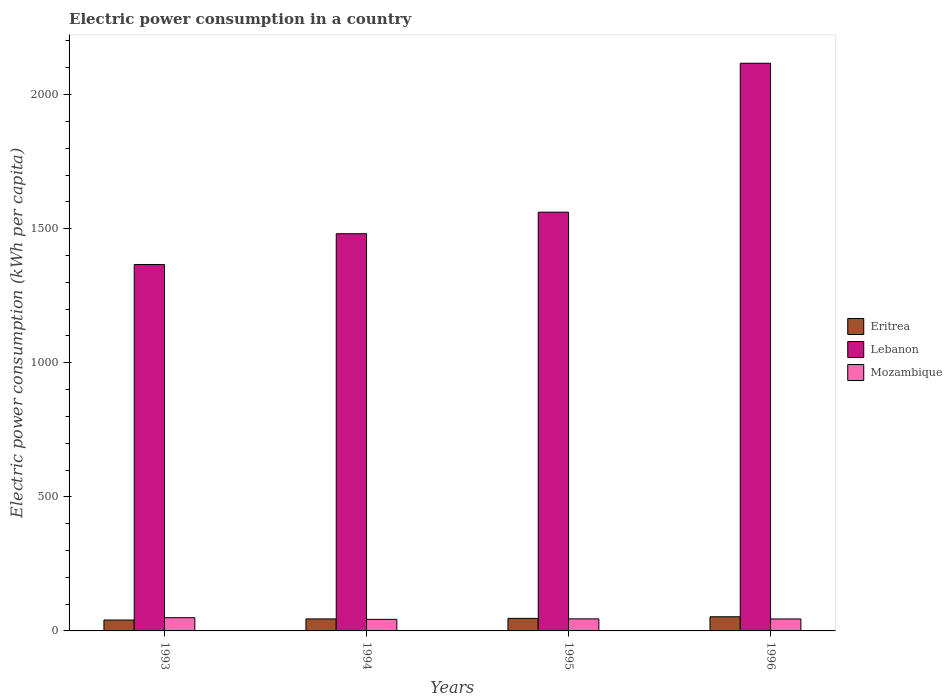How many different coloured bars are there?
Provide a succinct answer. 3. Are the number of bars on each tick of the X-axis equal?
Ensure brevity in your answer.  Yes. How many bars are there on the 2nd tick from the left?
Offer a terse response. 3. How many bars are there on the 3rd tick from the right?
Offer a terse response. 3. What is the electric power consumption in in Lebanon in 1994?
Your answer should be very brief. 1481.18. Across all years, what is the maximum electric power consumption in in Lebanon?
Offer a very short reply. 2116.92. Across all years, what is the minimum electric power consumption in in Eritrea?
Keep it short and to the point. 40.62. In which year was the electric power consumption in in Mozambique maximum?
Your answer should be very brief. 1993. In which year was the electric power consumption in in Eritrea minimum?
Offer a terse response. 1993. What is the total electric power consumption in in Eritrea in the graph?
Provide a short and direct response. 184.96. What is the difference between the electric power consumption in in Lebanon in 1995 and that in 1996?
Provide a short and direct response. -555.31. What is the difference between the electric power consumption in in Eritrea in 1993 and the electric power consumption in in Mozambique in 1996?
Provide a succinct answer. -3.98. What is the average electric power consumption in in Mozambique per year?
Provide a succinct answer. 45.47. In the year 1993, what is the difference between the electric power consumption in in Mozambique and electric power consumption in in Eritrea?
Your response must be concise. 8.65. In how many years, is the electric power consumption in in Eritrea greater than 1000 kWh per capita?
Provide a succinct answer. 0. What is the ratio of the electric power consumption in in Mozambique in 1994 to that in 1995?
Give a very brief answer. 0.96. Is the difference between the electric power consumption in in Mozambique in 1994 and 1996 greater than the difference between the electric power consumption in in Eritrea in 1994 and 1996?
Your answer should be compact. Yes. What is the difference between the highest and the second highest electric power consumption in in Eritrea?
Ensure brevity in your answer.  5.99. What is the difference between the highest and the lowest electric power consumption in in Eritrea?
Ensure brevity in your answer.  12.15. Is the sum of the electric power consumption in in Lebanon in 1993 and 1994 greater than the maximum electric power consumption in in Mozambique across all years?
Your response must be concise. Yes. What does the 1st bar from the left in 1995 represents?
Provide a short and direct response. Eritrea. What does the 2nd bar from the right in 1994 represents?
Make the answer very short. Lebanon. Is it the case that in every year, the sum of the electric power consumption in in Lebanon and electric power consumption in in Mozambique is greater than the electric power consumption in in Eritrea?
Your answer should be compact. Yes. How many years are there in the graph?
Offer a terse response. 4. Does the graph contain grids?
Provide a short and direct response. No. How many legend labels are there?
Your answer should be very brief. 3. How are the legend labels stacked?
Provide a succinct answer. Vertical. What is the title of the graph?
Keep it short and to the point. Electric power consumption in a country. What is the label or title of the Y-axis?
Give a very brief answer. Electric power consumption (kWh per capita). What is the Electric power consumption (kWh per capita) in Eritrea in 1993?
Provide a short and direct response. 40.62. What is the Electric power consumption (kWh per capita) in Lebanon in 1993?
Offer a terse response. 1366.49. What is the Electric power consumption (kWh per capita) of Mozambique in 1993?
Offer a terse response. 49.27. What is the Electric power consumption (kWh per capita) of Eritrea in 1994?
Keep it short and to the point. 44.79. What is the Electric power consumption (kWh per capita) in Lebanon in 1994?
Provide a succinct answer. 1481.18. What is the Electric power consumption (kWh per capita) in Mozambique in 1994?
Provide a short and direct response. 43.09. What is the Electric power consumption (kWh per capita) in Eritrea in 1995?
Ensure brevity in your answer.  46.77. What is the Electric power consumption (kWh per capita) of Lebanon in 1995?
Offer a terse response. 1561.61. What is the Electric power consumption (kWh per capita) of Mozambique in 1995?
Provide a succinct answer. 44.93. What is the Electric power consumption (kWh per capita) of Eritrea in 1996?
Keep it short and to the point. 52.77. What is the Electric power consumption (kWh per capita) in Lebanon in 1996?
Ensure brevity in your answer.  2116.92. What is the Electric power consumption (kWh per capita) of Mozambique in 1996?
Provide a succinct answer. 44.6. Across all years, what is the maximum Electric power consumption (kWh per capita) in Eritrea?
Provide a succinct answer. 52.77. Across all years, what is the maximum Electric power consumption (kWh per capita) of Lebanon?
Your answer should be compact. 2116.92. Across all years, what is the maximum Electric power consumption (kWh per capita) of Mozambique?
Give a very brief answer. 49.27. Across all years, what is the minimum Electric power consumption (kWh per capita) of Eritrea?
Give a very brief answer. 40.62. Across all years, what is the minimum Electric power consumption (kWh per capita) of Lebanon?
Ensure brevity in your answer.  1366.49. Across all years, what is the minimum Electric power consumption (kWh per capita) of Mozambique?
Provide a succinct answer. 43.09. What is the total Electric power consumption (kWh per capita) in Eritrea in the graph?
Provide a short and direct response. 184.96. What is the total Electric power consumption (kWh per capita) in Lebanon in the graph?
Your answer should be compact. 6526.2. What is the total Electric power consumption (kWh per capita) of Mozambique in the graph?
Offer a very short reply. 181.9. What is the difference between the Electric power consumption (kWh per capita) in Eritrea in 1993 and that in 1994?
Give a very brief answer. -4.17. What is the difference between the Electric power consumption (kWh per capita) in Lebanon in 1993 and that in 1994?
Your answer should be compact. -114.69. What is the difference between the Electric power consumption (kWh per capita) in Mozambique in 1993 and that in 1994?
Your answer should be very brief. 6.18. What is the difference between the Electric power consumption (kWh per capita) in Eritrea in 1993 and that in 1995?
Offer a very short reply. -6.15. What is the difference between the Electric power consumption (kWh per capita) of Lebanon in 1993 and that in 1995?
Offer a terse response. -195.12. What is the difference between the Electric power consumption (kWh per capita) in Mozambique in 1993 and that in 1995?
Provide a succinct answer. 4.34. What is the difference between the Electric power consumption (kWh per capita) in Eritrea in 1993 and that in 1996?
Provide a short and direct response. -12.15. What is the difference between the Electric power consumption (kWh per capita) in Lebanon in 1993 and that in 1996?
Your response must be concise. -750.43. What is the difference between the Electric power consumption (kWh per capita) in Mozambique in 1993 and that in 1996?
Give a very brief answer. 4.66. What is the difference between the Electric power consumption (kWh per capita) of Eritrea in 1994 and that in 1995?
Offer a terse response. -1.98. What is the difference between the Electric power consumption (kWh per capita) in Lebanon in 1994 and that in 1995?
Make the answer very short. -80.43. What is the difference between the Electric power consumption (kWh per capita) of Mozambique in 1994 and that in 1995?
Your answer should be compact. -1.84. What is the difference between the Electric power consumption (kWh per capita) in Eritrea in 1994 and that in 1996?
Provide a succinct answer. -7.98. What is the difference between the Electric power consumption (kWh per capita) of Lebanon in 1994 and that in 1996?
Ensure brevity in your answer.  -635.73. What is the difference between the Electric power consumption (kWh per capita) in Mozambique in 1994 and that in 1996?
Give a very brief answer. -1.51. What is the difference between the Electric power consumption (kWh per capita) of Eritrea in 1995 and that in 1996?
Keep it short and to the point. -5.99. What is the difference between the Electric power consumption (kWh per capita) in Lebanon in 1995 and that in 1996?
Keep it short and to the point. -555.31. What is the difference between the Electric power consumption (kWh per capita) in Mozambique in 1995 and that in 1996?
Provide a succinct answer. 0.33. What is the difference between the Electric power consumption (kWh per capita) of Eritrea in 1993 and the Electric power consumption (kWh per capita) of Lebanon in 1994?
Offer a very short reply. -1440.56. What is the difference between the Electric power consumption (kWh per capita) of Eritrea in 1993 and the Electric power consumption (kWh per capita) of Mozambique in 1994?
Your answer should be very brief. -2.47. What is the difference between the Electric power consumption (kWh per capita) of Lebanon in 1993 and the Electric power consumption (kWh per capita) of Mozambique in 1994?
Your answer should be compact. 1323.4. What is the difference between the Electric power consumption (kWh per capita) in Eritrea in 1993 and the Electric power consumption (kWh per capita) in Lebanon in 1995?
Your answer should be very brief. -1520.99. What is the difference between the Electric power consumption (kWh per capita) of Eritrea in 1993 and the Electric power consumption (kWh per capita) of Mozambique in 1995?
Your answer should be compact. -4.31. What is the difference between the Electric power consumption (kWh per capita) in Lebanon in 1993 and the Electric power consumption (kWh per capita) in Mozambique in 1995?
Make the answer very short. 1321.56. What is the difference between the Electric power consumption (kWh per capita) of Eritrea in 1993 and the Electric power consumption (kWh per capita) of Lebanon in 1996?
Your answer should be very brief. -2076.29. What is the difference between the Electric power consumption (kWh per capita) of Eritrea in 1993 and the Electric power consumption (kWh per capita) of Mozambique in 1996?
Your response must be concise. -3.98. What is the difference between the Electric power consumption (kWh per capita) in Lebanon in 1993 and the Electric power consumption (kWh per capita) in Mozambique in 1996?
Your answer should be compact. 1321.89. What is the difference between the Electric power consumption (kWh per capita) in Eritrea in 1994 and the Electric power consumption (kWh per capita) in Lebanon in 1995?
Give a very brief answer. -1516.82. What is the difference between the Electric power consumption (kWh per capita) in Eritrea in 1994 and the Electric power consumption (kWh per capita) in Mozambique in 1995?
Your response must be concise. -0.14. What is the difference between the Electric power consumption (kWh per capita) of Lebanon in 1994 and the Electric power consumption (kWh per capita) of Mozambique in 1995?
Keep it short and to the point. 1436.25. What is the difference between the Electric power consumption (kWh per capita) in Eritrea in 1994 and the Electric power consumption (kWh per capita) in Lebanon in 1996?
Offer a very short reply. -2072.13. What is the difference between the Electric power consumption (kWh per capita) in Eritrea in 1994 and the Electric power consumption (kWh per capita) in Mozambique in 1996?
Your answer should be compact. 0.19. What is the difference between the Electric power consumption (kWh per capita) in Lebanon in 1994 and the Electric power consumption (kWh per capita) in Mozambique in 1996?
Provide a succinct answer. 1436.58. What is the difference between the Electric power consumption (kWh per capita) of Eritrea in 1995 and the Electric power consumption (kWh per capita) of Lebanon in 1996?
Your answer should be very brief. -2070.14. What is the difference between the Electric power consumption (kWh per capita) in Eritrea in 1995 and the Electric power consumption (kWh per capita) in Mozambique in 1996?
Give a very brief answer. 2.17. What is the difference between the Electric power consumption (kWh per capita) in Lebanon in 1995 and the Electric power consumption (kWh per capita) in Mozambique in 1996?
Give a very brief answer. 1517.01. What is the average Electric power consumption (kWh per capita) of Eritrea per year?
Offer a very short reply. 46.24. What is the average Electric power consumption (kWh per capita) in Lebanon per year?
Ensure brevity in your answer.  1631.55. What is the average Electric power consumption (kWh per capita) of Mozambique per year?
Offer a terse response. 45.47. In the year 1993, what is the difference between the Electric power consumption (kWh per capita) of Eritrea and Electric power consumption (kWh per capita) of Lebanon?
Provide a short and direct response. -1325.87. In the year 1993, what is the difference between the Electric power consumption (kWh per capita) of Eritrea and Electric power consumption (kWh per capita) of Mozambique?
Your answer should be very brief. -8.64. In the year 1993, what is the difference between the Electric power consumption (kWh per capita) of Lebanon and Electric power consumption (kWh per capita) of Mozambique?
Your answer should be very brief. 1317.22. In the year 1994, what is the difference between the Electric power consumption (kWh per capita) of Eritrea and Electric power consumption (kWh per capita) of Lebanon?
Your response must be concise. -1436.39. In the year 1994, what is the difference between the Electric power consumption (kWh per capita) of Eritrea and Electric power consumption (kWh per capita) of Mozambique?
Offer a terse response. 1.7. In the year 1994, what is the difference between the Electric power consumption (kWh per capita) of Lebanon and Electric power consumption (kWh per capita) of Mozambique?
Your response must be concise. 1438.09. In the year 1995, what is the difference between the Electric power consumption (kWh per capita) of Eritrea and Electric power consumption (kWh per capita) of Lebanon?
Ensure brevity in your answer.  -1514.84. In the year 1995, what is the difference between the Electric power consumption (kWh per capita) of Eritrea and Electric power consumption (kWh per capita) of Mozambique?
Your answer should be compact. 1.84. In the year 1995, what is the difference between the Electric power consumption (kWh per capita) of Lebanon and Electric power consumption (kWh per capita) of Mozambique?
Your answer should be very brief. 1516.68. In the year 1996, what is the difference between the Electric power consumption (kWh per capita) in Eritrea and Electric power consumption (kWh per capita) in Lebanon?
Ensure brevity in your answer.  -2064.15. In the year 1996, what is the difference between the Electric power consumption (kWh per capita) in Eritrea and Electric power consumption (kWh per capita) in Mozambique?
Provide a short and direct response. 8.16. In the year 1996, what is the difference between the Electric power consumption (kWh per capita) of Lebanon and Electric power consumption (kWh per capita) of Mozambique?
Give a very brief answer. 2072.31. What is the ratio of the Electric power consumption (kWh per capita) in Eritrea in 1993 to that in 1994?
Offer a very short reply. 0.91. What is the ratio of the Electric power consumption (kWh per capita) of Lebanon in 1993 to that in 1994?
Offer a terse response. 0.92. What is the ratio of the Electric power consumption (kWh per capita) in Mozambique in 1993 to that in 1994?
Give a very brief answer. 1.14. What is the ratio of the Electric power consumption (kWh per capita) of Eritrea in 1993 to that in 1995?
Your response must be concise. 0.87. What is the ratio of the Electric power consumption (kWh per capita) of Lebanon in 1993 to that in 1995?
Keep it short and to the point. 0.88. What is the ratio of the Electric power consumption (kWh per capita) in Mozambique in 1993 to that in 1995?
Your response must be concise. 1.1. What is the ratio of the Electric power consumption (kWh per capita) in Eritrea in 1993 to that in 1996?
Your answer should be compact. 0.77. What is the ratio of the Electric power consumption (kWh per capita) in Lebanon in 1993 to that in 1996?
Your answer should be compact. 0.65. What is the ratio of the Electric power consumption (kWh per capita) of Mozambique in 1993 to that in 1996?
Keep it short and to the point. 1.1. What is the ratio of the Electric power consumption (kWh per capita) of Eritrea in 1994 to that in 1995?
Provide a short and direct response. 0.96. What is the ratio of the Electric power consumption (kWh per capita) of Lebanon in 1994 to that in 1995?
Offer a terse response. 0.95. What is the ratio of the Electric power consumption (kWh per capita) of Mozambique in 1994 to that in 1995?
Your answer should be very brief. 0.96. What is the ratio of the Electric power consumption (kWh per capita) of Eritrea in 1994 to that in 1996?
Offer a very short reply. 0.85. What is the ratio of the Electric power consumption (kWh per capita) in Lebanon in 1994 to that in 1996?
Provide a short and direct response. 0.7. What is the ratio of the Electric power consumption (kWh per capita) in Mozambique in 1994 to that in 1996?
Provide a short and direct response. 0.97. What is the ratio of the Electric power consumption (kWh per capita) in Eritrea in 1995 to that in 1996?
Offer a very short reply. 0.89. What is the ratio of the Electric power consumption (kWh per capita) in Lebanon in 1995 to that in 1996?
Offer a terse response. 0.74. What is the ratio of the Electric power consumption (kWh per capita) in Mozambique in 1995 to that in 1996?
Your response must be concise. 1.01. What is the difference between the highest and the second highest Electric power consumption (kWh per capita) of Eritrea?
Your response must be concise. 5.99. What is the difference between the highest and the second highest Electric power consumption (kWh per capita) of Lebanon?
Your answer should be compact. 555.31. What is the difference between the highest and the second highest Electric power consumption (kWh per capita) in Mozambique?
Provide a succinct answer. 4.34. What is the difference between the highest and the lowest Electric power consumption (kWh per capita) in Eritrea?
Your answer should be compact. 12.15. What is the difference between the highest and the lowest Electric power consumption (kWh per capita) of Lebanon?
Offer a very short reply. 750.43. What is the difference between the highest and the lowest Electric power consumption (kWh per capita) in Mozambique?
Ensure brevity in your answer.  6.18. 